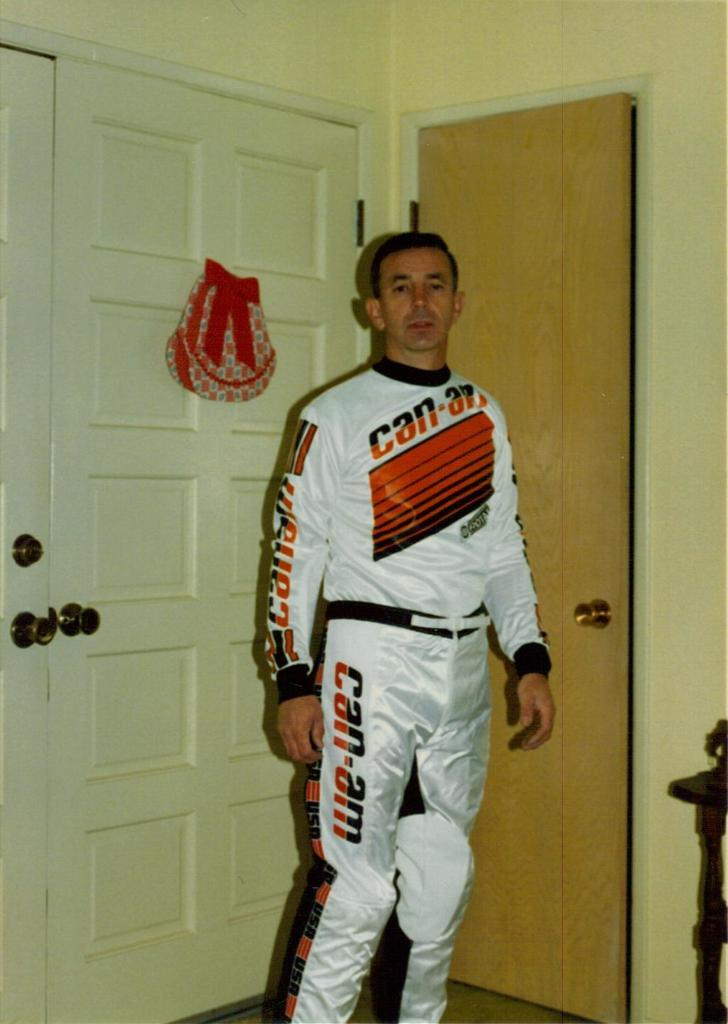<image>
Create a compact narrative representing the image presented. A man wears a uniform with the Can-Am name on the shirt and the pants. 